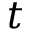Convert formula to latex. <formula><loc_0><loc_0><loc_500><loc_500>t</formula> 